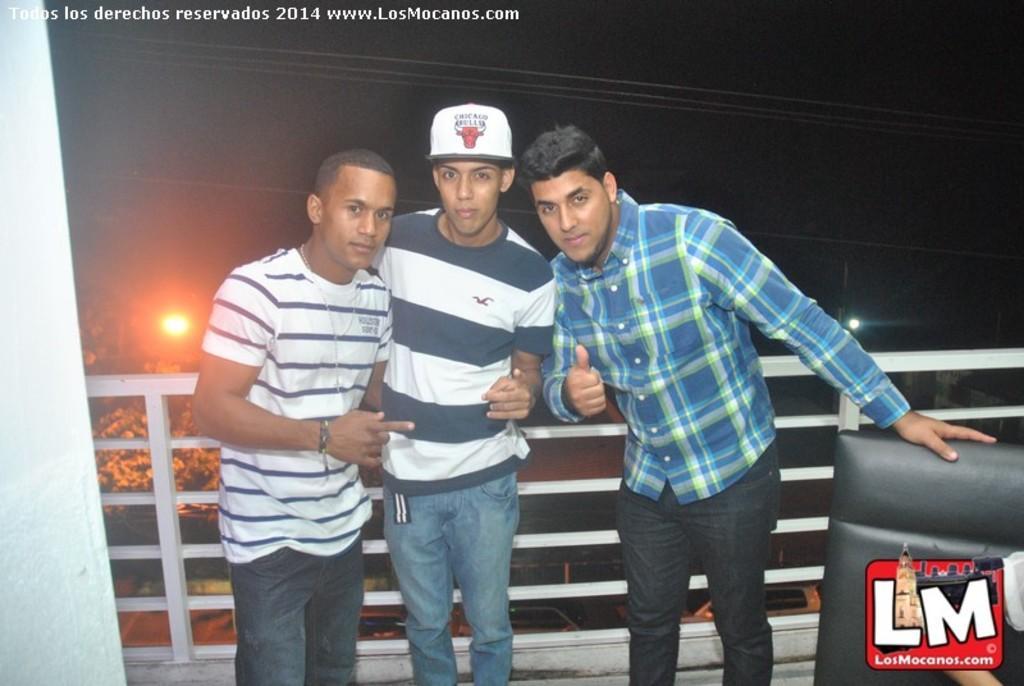Could you give a brief overview of what you see in this image? In this image we can see three persons standing on the floor, there is a black color object looks like a chair beside the person and on the left side there is a wall and in the background there is an iron railing, tree, lights, wires and cars on the road. 